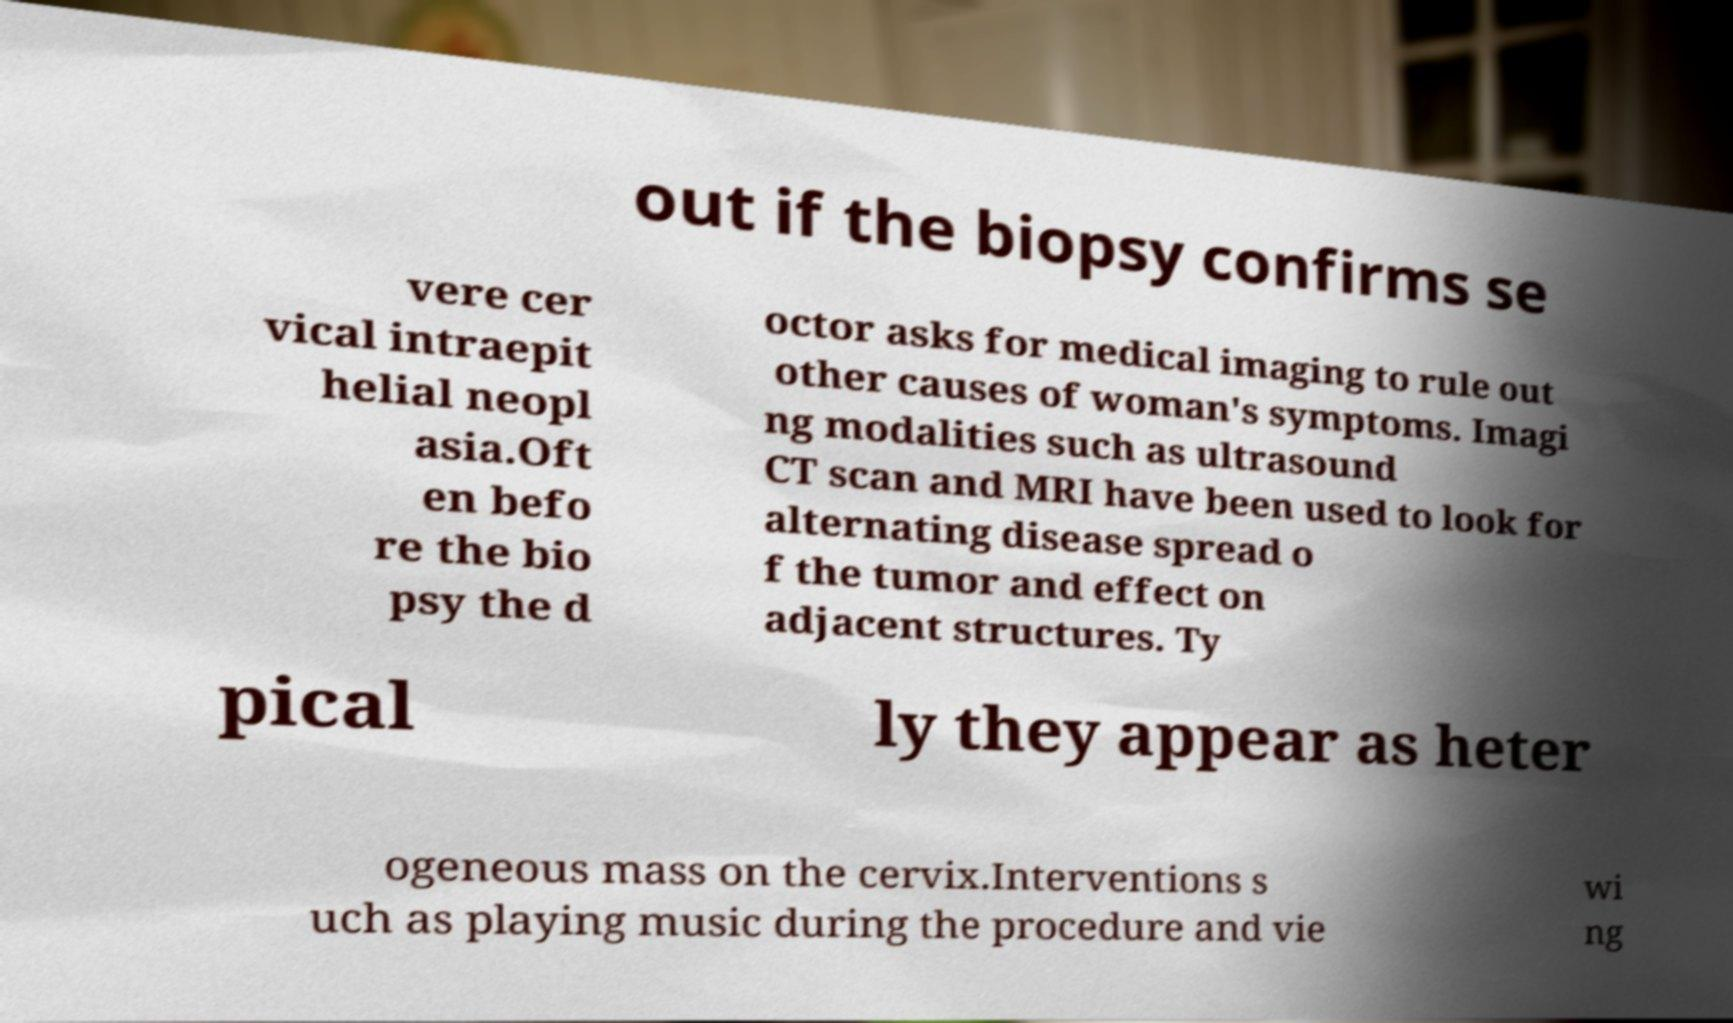Could you assist in decoding the text presented in this image and type it out clearly? out if the biopsy confirms se vere cer vical intraepit helial neopl asia.Oft en befo re the bio psy the d octor asks for medical imaging to rule out other causes of woman's symptoms. Imagi ng modalities such as ultrasound CT scan and MRI have been used to look for alternating disease spread o f the tumor and effect on adjacent structures. Ty pical ly they appear as heter ogeneous mass on the cervix.Interventions s uch as playing music during the procedure and vie wi ng 